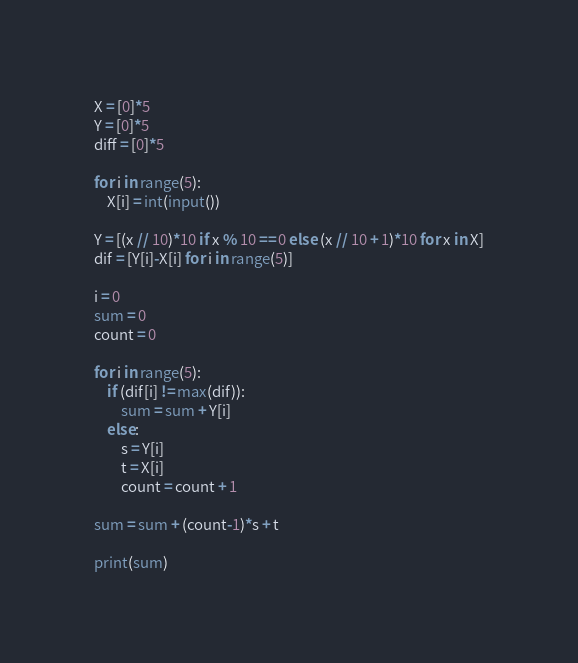Convert code to text. <code><loc_0><loc_0><loc_500><loc_500><_Python_>X = [0]*5
Y = [0]*5
diff = [0]*5

for i in range(5):
    X[i] = int(input())

Y = [(x // 10)*10 if x % 10 == 0 else (x // 10 + 1)*10 for x in X]
dif = [Y[i]-X[i] for i in range(5)]

i = 0
sum = 0
count = 0

for i in range(5):
    if (dif[i] != max(dif)):
        sum = sum + Y[i]
    else:
        s = Y[i]
        t = X[i]
        count = count + 1

sum = sum + (count-1)*s + t

print(sum)</code> 